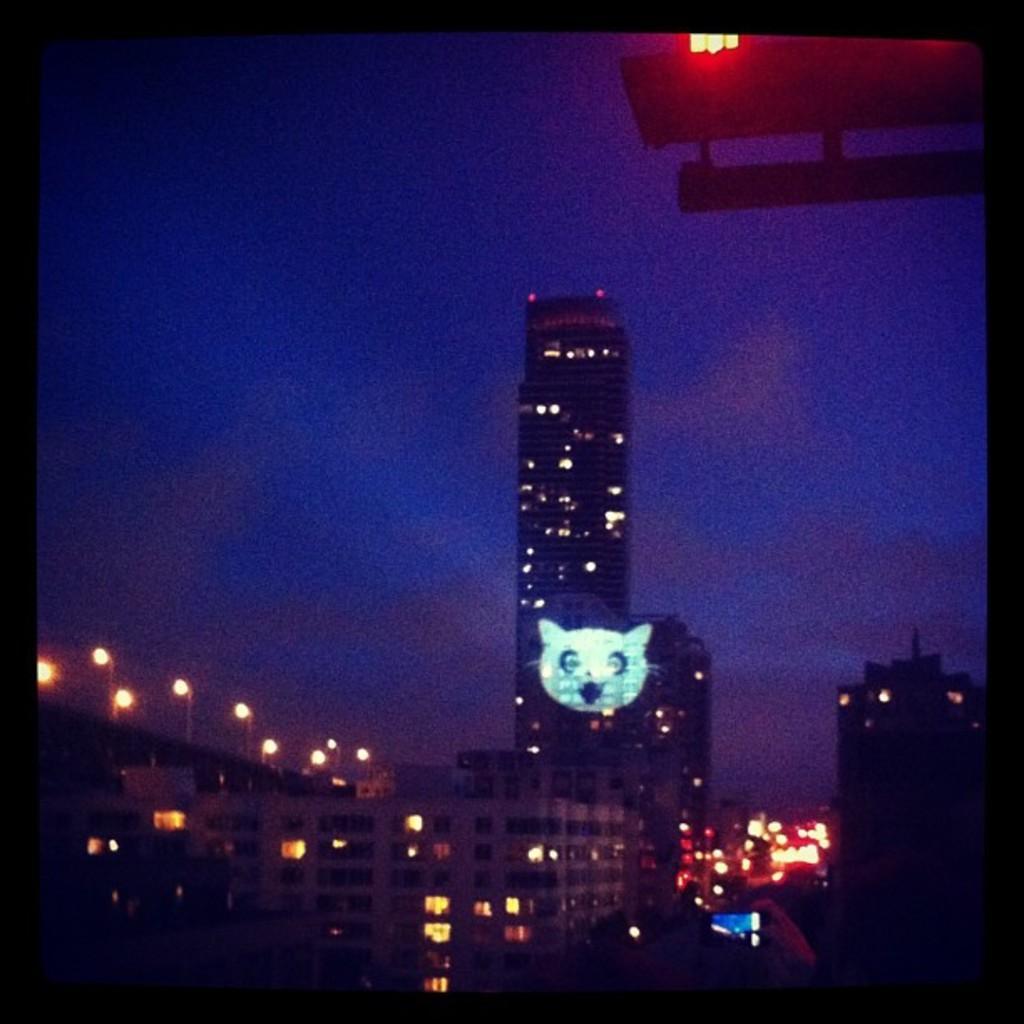Describe this image in one or two sentences. In the image there are many buildings with lights. And also there are poles with street lights. And there is a dark background. 